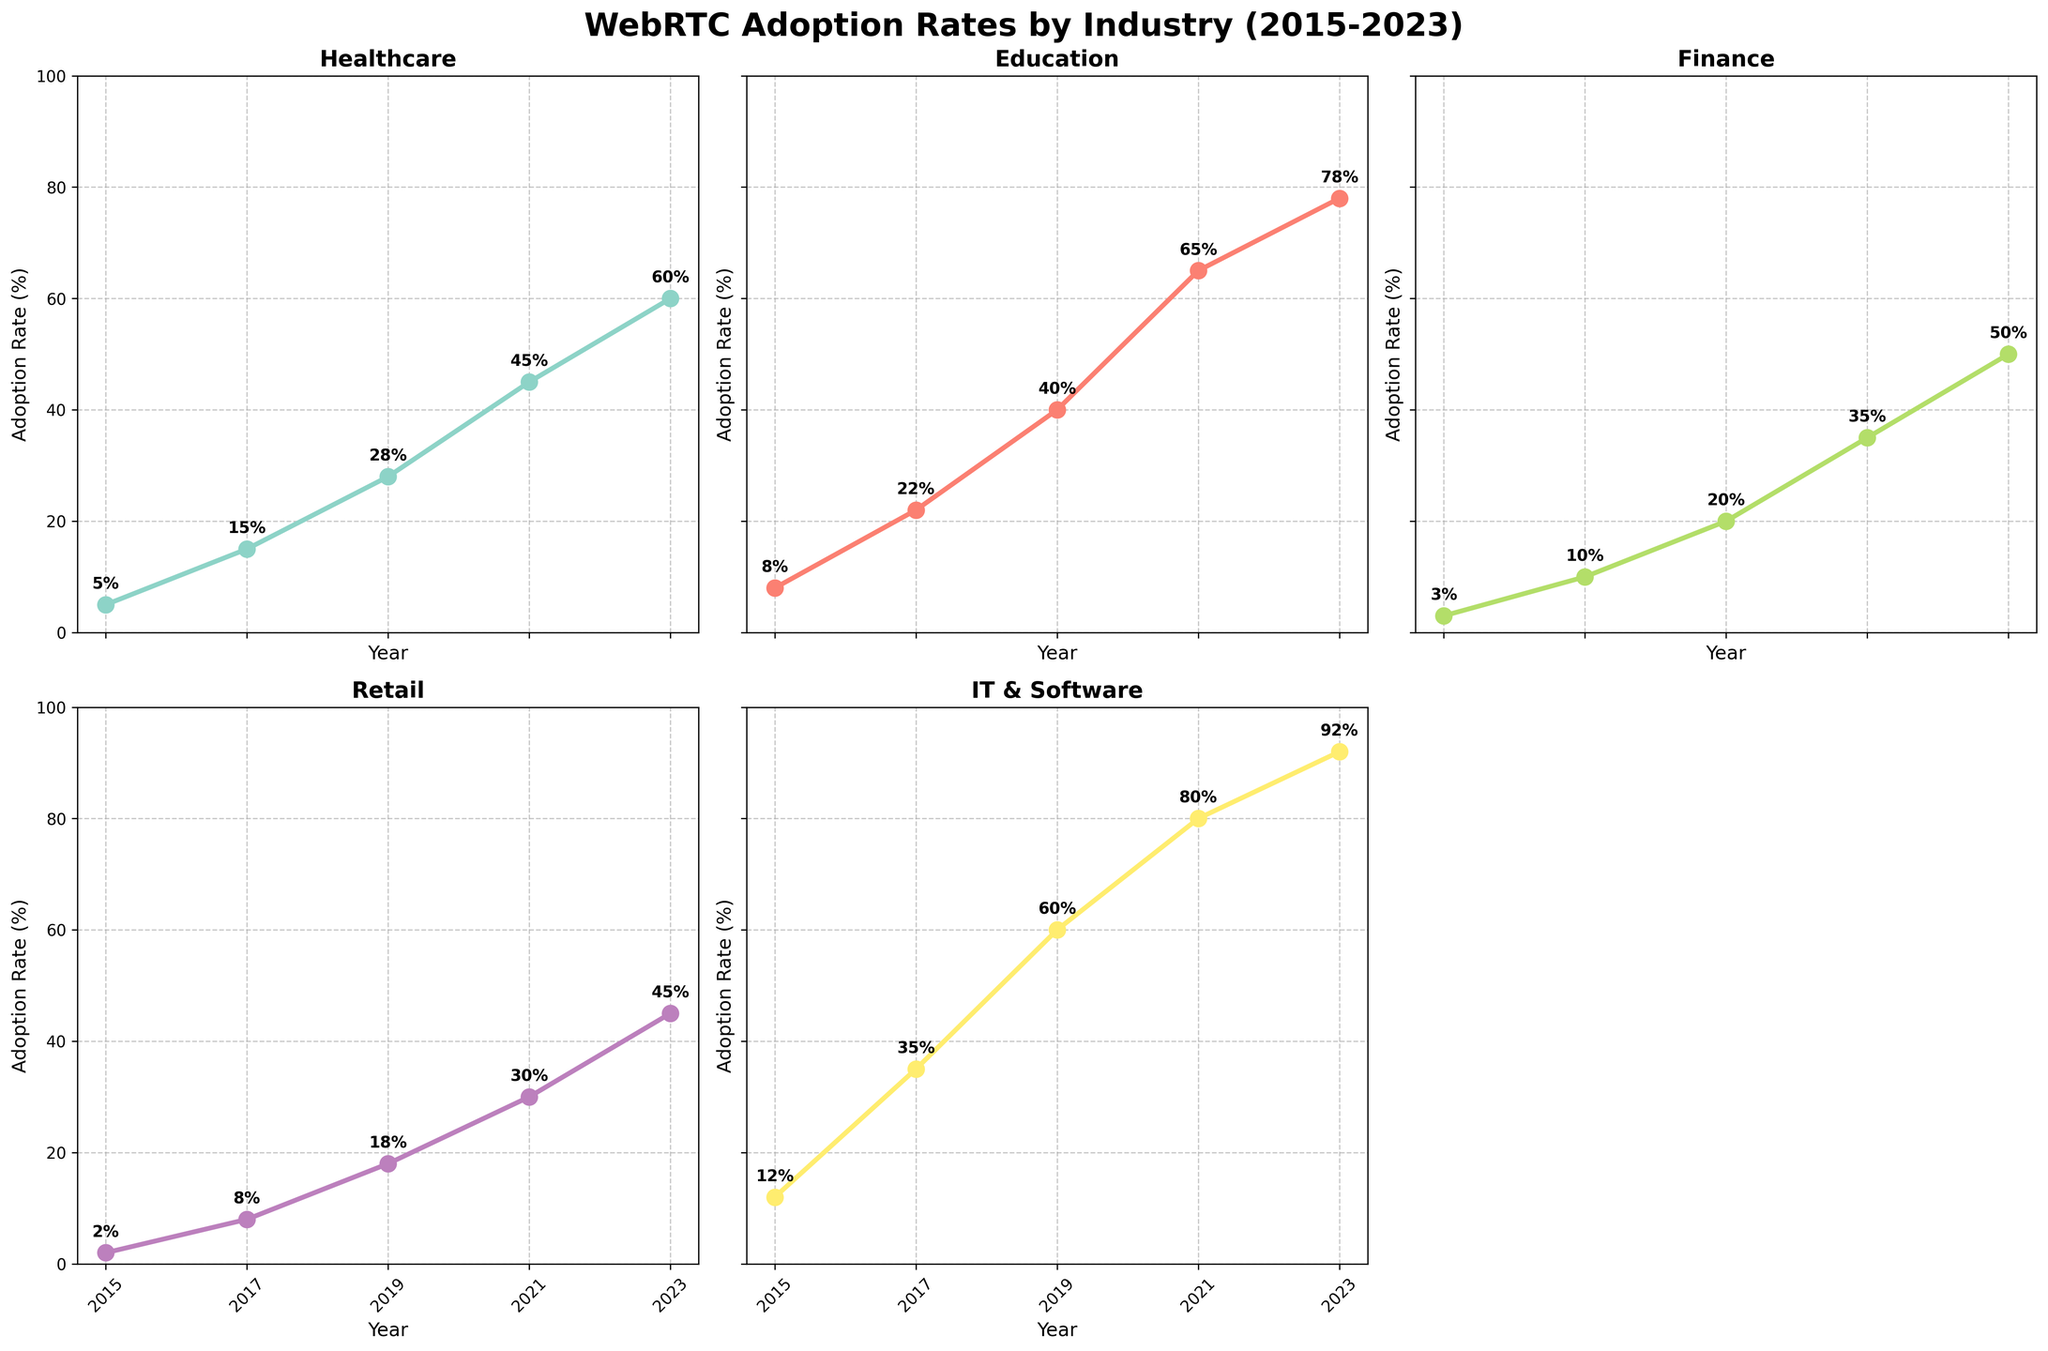What is the adoption rate of WebRTC in the Healthcare industry in 2023? The adoption rate is labeled next to the data point for the year 2023 under the Healthcare subplot.
Answer: 60% Which industry had the highest adoption rate of WebRTC in 2021? Among all subplots, the highest y-axis value in 2021 is under IT & Software.
Answer: IT & Software How much did the adoption rate in the Finance industry increase from 2015 to 2019? The adoption rate in Finance was 3% in 2015 and 20% in 2019. The increase is calculated as 20% - 3%.
Answer: 17% Compare the adoption rates of WebRTC in Healthcare and Education in 2019. Which has a higher rate and by how much? In 2019, Healthcare had 28% and Education had 40%. Compare the two numbers: 40% is higher than 28% by the difference 40% - 28%.
Answer: Education by 12% What is the average adoption rate of WebRTC in the Retail industry from 2015 to 2023? The adoption rates for Retail from 2015 to 2023 are 2%, 8%, 18%, 30%, and 45%. The average is calculated by summing these values and dividing by the count. (2+8+18+30+45)/5 = 103/5.
Answer: 20.6% Which industry showed the most significant increase in WebRTC adoption rate between 2015 and 2023? By checking each subplot, calculate the difference between the adoption rates in 2023 and 2015. The largest increase is seen in IT & Software from 12% to 92%, an increase of 80%.
Answer: IT & Software What was the adoption rate trend in the Healthcare industry from 2015 to 2023? In the Healthcare industry subplot, the adoption rate increases consistently from 5% in 2015 to 60% in 2023, indicating a steady upward trend.
Answer: Steady upward trend How many industries have an adoption rate exceeding 50% in 2023? Under each subplot for the year 2023, counting the number of industries with rates over 50%: Healthcare (60%), Education (78%), Finance (50%, not exceeding), Retail (45%, not exceeding), IT & Software (92%).
Answer: 3 industries Between 2017 and 2021, which industry had the smallest increase in WebRTC adoption rate? Compute the increase for each industry between these years: Healthcare (45-15), Education (65-22), Finance (35-10), Retail (30-8), IT & Software (80-35). The smallest increase (22) is in Retail.
Answer: Retail 